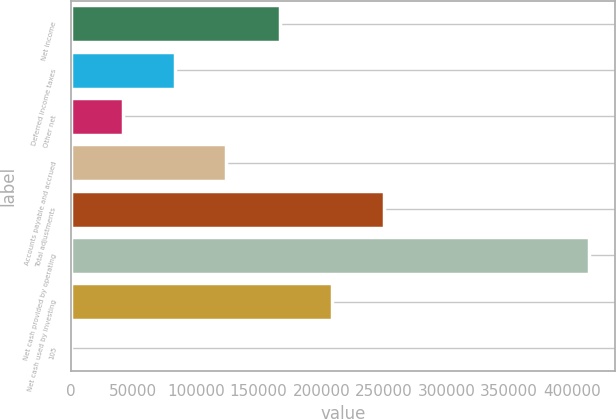<chart> <loc_0><loc_0><loc_500><loc_500><bar_chart><fcel>Net income<fcel>Deferred income taxes<fcel>Other net<fcel>Accounts payable and accrued<fcel>Total adjustments<fcel>Net cash provided by operating<fcel>Net cash used by investing<fcel>105<nl><fcel>167445<fcel>82861.6<fcel>41483.3<fcel>124240<fcel>250202<fcel>413888<fcel>208823<fcel>105<nl></chart> 